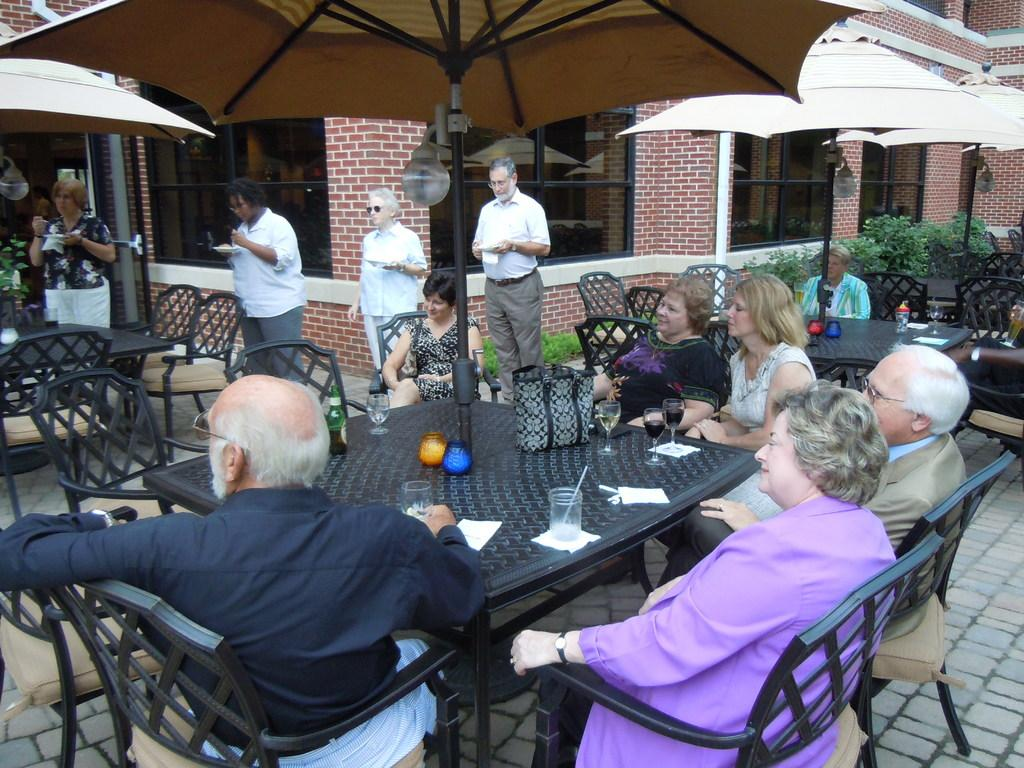How many people are in the image? There is a group of people in the image. What are the people doing in the image? The people are sitting on chairs around a dining table. What is in the middle of the table? There is an umbrella in the middle of the table. What can be seen on the right side of the image? There are bushes on the right side of the image. Can you see any spots on the crackers in the image? There are no crackers present in the image, so it is not possible to see any spots on them. Are there any cacti visible in the image? There are no cacti present in the image; the only vegetation mentioned is bushes on the right side. 